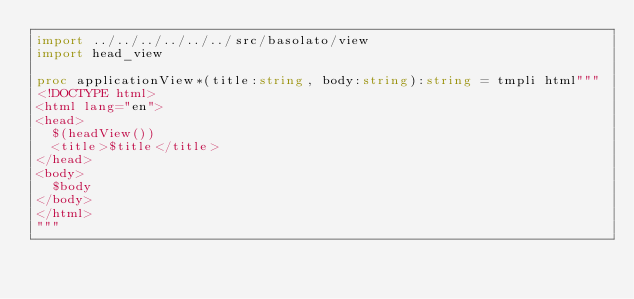<code> <loc_0><loc_0><loc_500><loc_500><_Nim_>import ../../../../../../src/basolato/view
import head_view

proc applicationView*(title:string, body:string):string = tmpli html"""
<!DOCTYPE html>
<html lang="en">
<head>
  $(headView())
  <title>$title</title>
</head>
<body>
  $body
</body>
</html>
"""
</code> 